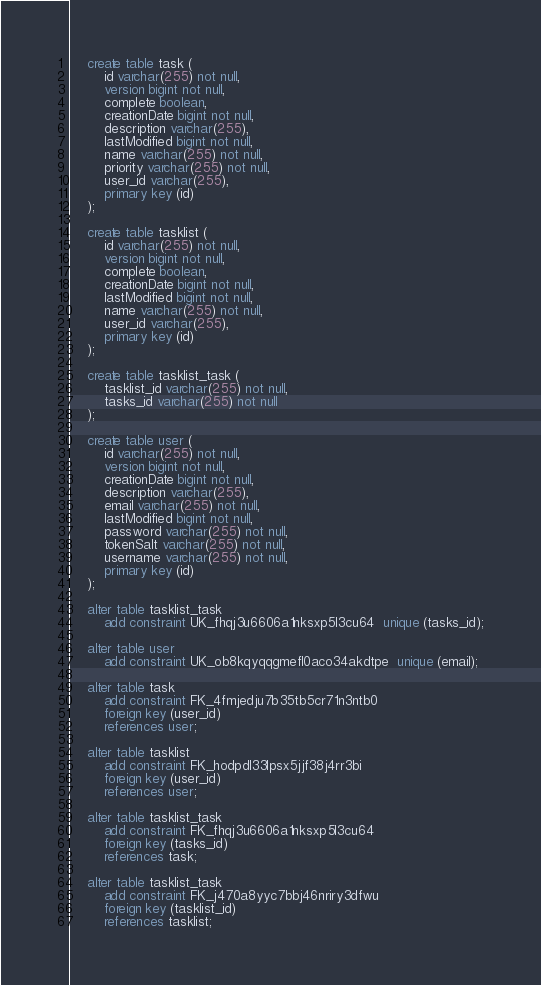Convert code to text. <code><loc_0><loc_0><loc_500><loc_500><_SQL_>
    create table task (
        id varchar(255) not null,
        version bigint not null,
        complete boolean,
        creationDate bigint not null,
        description varchar(255),
        lastModified bigint not null,
        name varchar(255) not null,
        priority varchar(255) not null,
        user_id varchar(255),
        primary key (id)
    );

    create table tasklist (
        id varchar(255) not null,
        version bigint not null,
        complete boolean,
        creationDate bigint not null,
        lastModified bigint not null,
        name varchar(255) not null,
        user_id varchar(255),
        primary key (id)
    );

    create table tasklist_task (
        tasklist_id varchar(255) not null,
        tasks_id varchar(255) not null
    );

    create table user (
        id varchar(255) not null,
        version bigint not null,
        creationDate bigint not null,
        description varchar(255),
        email varchar(255) not null,
        lastModified bigint not null,
        password varchar(255) not null,
        tokenSalt varchar(255) not null,
        username varchar(255) not null,
        primary key (id)
    );

    alter table tasklist_task 
        add constraint UK_fhqj3u6606a1nksxp5l3cu64  unique (tasks_id);

    alter table user 
        add constraint UK_ob8kqyqqgmefl0aco34akdtpe  unique (email);

    alter table task 
        add constraint FK_4fmjedju7b35tb5cr71n3ntb0 
        foreign key (user_id) 
        references user;

    alter table tasklist 
        add constraint FK_hodpdl33lpsx5jjf38j4rr3bi 
        foreign key (user_id) 
        references user;

    alter table tasklist_task 
        add constraint FK_fhqj3u6606a1nksxp5l3cu64 
        foreign key (tasks_id) 
        references task;

    alter table tasklist_task 
        add constraint FK_j470a8yyc7bbj46nriry3dfwu 
        foreign key (tasklist_id) 
        references tasklist;
</code> 